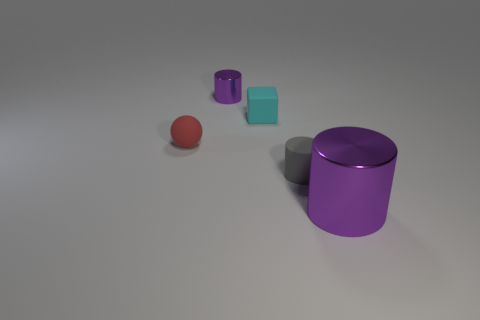Subtract all purple cylinders. Subtract all gray blocks. How many cylinders are left? 1 Add 4 yellow rubber cylinders. How many objects exist? 9 Subtract all cylinders. How many objects are left? 2 Subtract all green rubber objects. Subtract all purple cylinders. How many objects are left? 3 Add 1 cubes. How many cubes are left? 2 Add 3 red metal things. How many red metal things exist? 3 Subtract 0 blue spheres. How many objects are left? 5 